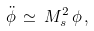<formula> <loc_0><loc_0><loc_500><loc_500>\ddot { \phi } \, \simeq \, M _ { s } ^ { 2 } \, \phi \, ,</formula> 